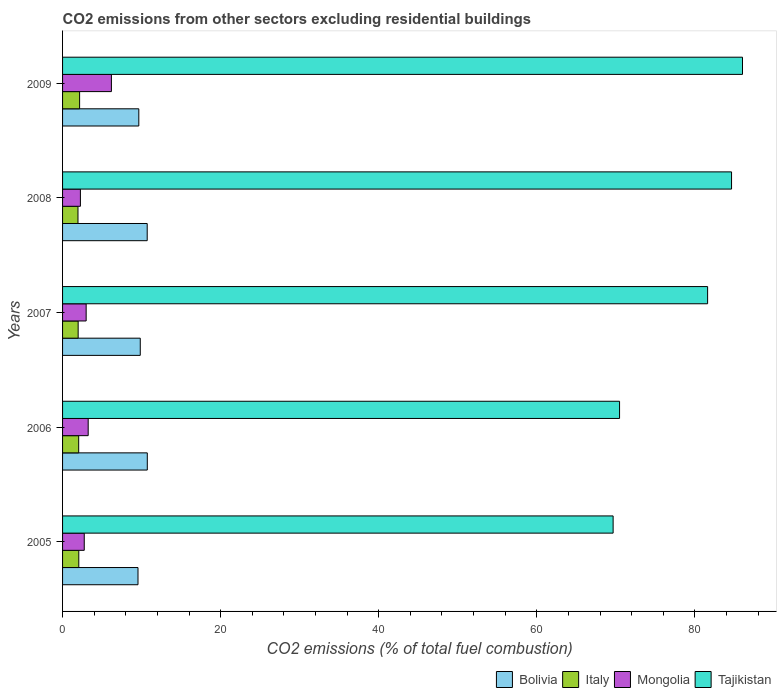How many different coloured bars are there?
Your answer should be very brief. 4. Are the number of bars per tick equal to the number of legend labels?
Offer a terse response. Yes. Are the number of bars on each tick of the Y-axis equal?
Keep it short and to the point. Yes. How many bars are there on the 4th tick from the bottom?
Your answer should be compact. 4. What is the total CO2 emitted in Bolivia in 2009?
Give a very brief answer. 9.65. Across all years, what is the maximum total CO2 emitted in Bolivia?
Offer a terse response. 10.72. Across all years, what is the minimum total CO2 emitted in Italy?
Provide a succinct answer. 1.95. In which year was the total CO2 emitted in Italy maximum?
Make the answer very short. 2009. In which year was the total CO2 emitted in Tajikistan minimum?
Your response must be concise. 2005. What is the total total CO2 emitted in Bolivia in the graph?
Keep it short and to the point. 50.45. What is the difference between the total CO2 emitted in Bolivia in 2006 and that in 2008?
Your answer should be compact. 0.01. What is the difference between the total CO2 emitted in Mongolia in 2005 and the total CO2 emitted in Italy in 2009?
Provide a short and direct response. 0.59. What is the average total CO2 emitted in Italy per year?
Provide a short and direct response. 2.03. In the year 2006, what is the difference between the total CO2 emitted in Mongolia and total CO2 emitted in Bolivia?
Keep it short and to the point. -7.48. In how many years, is the total CO2 emitted in Tajikistan greater than 28 ?
Offer a very short reply. 5. What is the ratio of the total CO2 emitted in Bolivia in 2005 to that in 2006?
Your response must be concise. 0.89. Is the difference between the total CO2 emitted in Mongolia in 2006 and 2008 greater than the difference between the total CO2 emitted in Bolivia in 2006 and 2008?
Ensure brevity in your answer.  Yes. What is the difference between the highest and the second highest total CO2 emitted in Bolivia?
Your answer should be very brief. 0.01. What is the difference between the highest and the lowest total CO2 emitted in Bolivia?
Your answer should be very brief. 1.18. In how many years, is the total CO2 emitted in Tajikistan greater than the average total CO2 emitted in Tajikistan taken over all years?
Ensure brevity in your answer.  3. What does the 4th bar from the top in 2009 represents?
Keep it short and to the point. Bolivia. What does the 3rd bar from the bottom in 2006 represents?
Make the answer very short. Mongolia. How many bars are there?
Your answer should be compact. 20. Are all the bars in the graph horizontal?
Your answer should be compact. Yes. How many years are there in the graph?
Offer a very short reply. 5. What is the difference between two consecutive major ticks on the X-axis?
Offer a terse response. 20. Does the graph contain grids?
Your response must be concise. No. How many legend labels are there?
Ensure brevity in your answer.  4. What is the title of the graph?
Your answer should be very brief. CO2 emissions from other sectors excluding residential buildings. Does "Singapore" appear as one of the legend labels in the graph?
Offer a terse response. No. What is the label or title of the X-axis?
Provide a succinct answer. CO2 emissions (% of total fuel combustion). What is the label or title of the Y-axis?
Provide a succinct answer. Years. What is the CO2 emissions (% of total fuel combustion) of Bolivia in 2005?
Your response must be concise. 9.54. What is the CO2 emissions (% of total fuel combustion) of Italy in 2005?
Offer a very short reply. 2.05. What is the CO2 emissions (% of total fuel combustion) in Mongolia in 2005?
Provide a short and direct response. 2.74. What is the CO2 emissions (% of total fuel combustion) in Tajikistan in 2005?
Offer a very short reply. 69.66. What is the CO2 emissions (% of total fuel combustion) of Bolivia in 2006?
Make the answer very short. 10.72. What is the CO2 emissions (% of total fuel combustion) in Italy in 2006?
Offer a terse response. 2.04. What is the CO2 emissions (% of total fuel combustion) of Mongolia in 2006?
Your response must be concise. 3.24. What is the CO2 emissions (% of total fuel combustion) in Tajikistan in 2006?
Provide a short and direct response. 70.47. What is the CO2 emissions (% of total fuel combustion) of Bolivia in 2007?
Provide a short and direct response. 9.83. What is the CO2 emissions (% of total fuel combustion) in Italy in 2007?
Your answer should be very brief. 1.97. What is the CO2 emissions (% of total fuel combustion) of Mongolia in 2007?
Offer a terse response. 2.98. What is the CO2 emissions (% of total fuel combustion) of Tajikistan in 2007?
Provide a succinct answer. 81.61. What is the CO2 emissions (% of total fuel combustion) in Bolivia in 2008?
Ensure brevity in your answer.  10.71. What is the CO2 emissions (% of total fuel combustion) in Italy in 2008?
Your answer should be very brief. 1.95. What is the CO2 emissions (% of total fuel combustion) of Mongolia in 2008?
Your answer should be compact. 2.26. What is the CO2 emissions (% of total fuel combustion) of Tajikistan in 2008?
Provide a short and direct response. 84.64. What is the CO2 emissions (% of total fuel combustion) in Bolivia in 2009?
Your response must be concise. 9.65. What is the CO2 emissions (% of total fuel combustion) of Italy in 2009?
Keep it short and to the point. 2.16. What is the CO2 emissions (% of total fuel combustion) of Mongolia in 2009?
Give a very brief answer. 6.18. What is the CO2 emissions (% of total fuel combustion) of Tajikistan in 2009?
Offer a terse response. 86.03. Across all years, what is the maximum CO2 emissions (% of total fuel combustion) in Bolivia?
Offer a terse response. 10.72. Across all years, what is the maximum CO2 emissions (% of total fuel combustion) of Italy?
Your response must be concise. 2.16. Across all years, what is the maximum CO2 emissions (% of total fuel combustion) in Mongolia?
Provide a succinct answer. 6.18. Across all years, what is the maximum CO2 emissions (% of total fuel combustion) in Tajikistan?
Your response must be concise. 86.03. Across all years, what is the minimum CO2 emissions (% of total fuel combustion) of Bolivia?
Make the answer very short. 9.54. Across all years, what is the minimum CO2 emissions (% of total fuel combustion) of Italy?
Keep it short and to the point. 1.95. Across all years, what is the minimum CO2 emissions (% of total fuel combustion) in Mongolia?
Offer a terse response. 2.26. Across all years, what is the minimum CO2 emissions (% of total fuel combustion) in Tajikistan?
Keep it short and to the point. 69.66. What is the total CO2 emissions (% of total fuel combustion) of Bolivia in the graph?
Keep it short and to the point. 50.45. What is the total CO2 emissions (% of total fuel combustion) of Italy in the graph?
Give a very brief answer. 10.17. What is the total CO2 emissions (% of total fuel combustion) in Mongolia in the graph?
Provide a succinct answer. 17.4. What is the total CO2 emissions (% of total fuel combustion) of Tajikistan in the graph?
Your response must be concise. 392.41. What is the difference between the CO2 emissions (% of total fuel combustion) in Bolivia in 2005 and that in 2006?
Your answer should be very brief. -1.18. What is the difference between the CO2 emissions (% of total fuel combustion) in Italy in 2005 and that in 2006?
Keep it short and to the point. 0.01. What is the difference between the CO2 emissions (% of total fuel combustion) in Mongolia in 2005 and that in 2006?
Keep it short and to the point. -0.5. What is the difference between the CO2 emissions (% of total fuel combustion) of Tajikistan in 2005 and that in 2006?
Your answer should be compact. -0.81. What is the difference between the CO2 emissions (% of total fuel combustion) of Bolivia in 2005 and that in 2007?
Keep it short and to the point. -0.29. What is the difference between the CO2 emissions (% of total fuel combustion) of Italy in 2005 and that in 2007?
Ensure brevity in your answer.  0.08. What is the difference between the CO2 emissions (% of total fuel combustion) of Mongolia in 2005 and that in 2007?
Provide a short and direct response. -0.24. What is the difference between the CO2 emissions (% of total fuel combustion) of Tajikistan in 2005 and that in 2007?
Give a very brief answer. -11.95. What is the difference between the CO2 emissions (% of total fuel combustion) of Bolivia in 2005 and that in 2008?
Your answer should be very brief. -1.16. What is the difference between the CO2 emissions (% of total fuel combustion) in Italy in 2005 and that in 2008?
Provide a succinct answer. 0.1. What is the difference between the CO2 emissions (% of total fuel combustion) of Mongolia in 2005 and that in 2008?
Keep it short and to the point. 0.49. What is the difference between the CO2 emissions (% of total fuel combustion) of Tajikistan in 2005 and that in 2008?
Ensure brevity in your answer.  -14.98. What is the difference between the CO2 emissions (% of total fuel combustion) of Bolivia in 2005 and that in 2009?
Your answer should be very brief. -0.1. What is the difference between the CO2 emissions (% of total fuel combustion) of Italy in 2005 and that in 2009?
Offer a very short reply. -0.1. What is the difference between the CO2 emissions (% of total fuel combustion) in Mongolia in 2005 and that in 2009?
Your answer should be compact. -3.44. What is the difference between the CO2 emissions (% of total fuel combustion) in Tajikistan in 2005 and that in 2009?
Provide a succinct answer. -16.37. What is the difference between the CO2 emissions (% of total fuel combustion) of Bolivia in 2006 and that in 2007?
Your answer should be very brief. 0.89. What is the difference between the CO2 emissions (% of total fuel combustion) of Italy in 2006 and that in 2007?
Your answer should be compact. 0.07. What is the difference between the CO2 emissions (% of total fuel combustion) of Mongolia in 2006 and that in 2007?
Offer a terse response. 0.26. What is the difference between the CO2 emissions (% of total fuel combustion) in Tajikistan in 2006 and that in 2007?
Provide a short and direct response. -11.14. What is the difference between the CO2 emissions (% of total fuel combustion) in Bolivia in 2006 and that in 2008?
Give a very brief answer. 0.01. What is the difference between the CO2 emissions (% of total fuel combustion) of Italy in 2006 and that in 2008?
Ensure brevity in your answer.  0.09. What is the difference between the CO2 emissions (% of total fuel combustion) in Mongolia in 2006 and that in 2008?
Provide a short and direct response. 0.98. What is the difference between the CO2 emissions (% of total fuel combustion) in Tajikistan in 2006 and that in 2008?
Your answer should be very brief. -14.17. What is the difference between the CO2 emissions (% of total fuel combustion) in Bolivia in 2006 and that in 2009?
Provide a succinct answer. 1.07. What is the difference between the CO2 emissions (% of total fuel combustion) in Italy in 2006 and that in 2009?
Offer a terse response. -0.12. What is the difference between the CO2 emissions (% of total fuel combustion) of Mongolia in 2006 and that in 2009?
Keep it short and to the point. -2.94. What is the difference between the CO2 emissions (% of total fuel combustion) in Tajikistan in 2006 and that in 2009?
Provide a succinct answer. -15.55. What is the difference between the CO2 emissions (% of total fuel combustion) of Bolivia in 2007 and that in 2008?
Provide a succinct answer. -0.88. What is the difference between the CO2 emissions (% of total fuel combustion) in Italy in 2007 and that in 2008?
Offer a very short reply. 0.02. What is the difference between the CO2 emissions (% of total fuel combustion) of Mongolia in 2007 and that in 2008?
Make the answer very short. 0.73. What is the difference between the CO2 emissions (% of total fuel combustion) of Tajikistan in 2007 and that in 2008?
Your answer should be very brief. -3.03. What is the difference between the CO2 emissions (% of total fuel combustion) of Bolivia in 2007 and that in 2009?
Give a very brief answer. 0.18. What is the difference between the CO2 emissions (% of total fuel combustion) of Italy in 2007 and that in 2009?
Make the answer very short. -0.18. What is the difference between the CO2 emissions (% of total fuel combustion) in Mongolia in 2007 and that in 2009?
Your answer should be very brief. -3.2. What is the difference between the CO2 emissions (% of total fuel combustion) of Tajikistan in 2007 and that in 2009?
Offer a terse response. -4.41. What is the difference between the CO2 emissions (% of total fuel combustion) of Bolivia in 2008 and that in 2009?
Your answer should be very brief. 1.06. What is the difference between the CO2 emissions (% of total fuel combustion) in Italy in 2008 and that in 2009?
Keep it short and to the point. -0.21. What is the difference between the CO2 emissions (% of total fuel combustion) of Mongolia in 2008 and that in 2009?
Offer a terse response. -3.92. What is the difference between the CO2 emissions (% of total fuel combustion) in Tajikistan in 2008 and that in 2009?
Provide a short and direct response. -1.38. What is the difference between the CO2 emissions (% of total fuel combustion) in Bolivia in 2005 and the CO2 emissions (% of total fuel combustion) in Italy in 2006?
Ensure brevity in your answer.  7.5. What is the difference between the CO2 emissions (% of total fuel combustion) of Bolivia in 2005 and the CO2 emissions (% of total fuel combustion) of Mongolia in 2006?
Make the answer very short. 6.3. What is the difference between the CO2 emissions (% of total fuel combustion) in Bolivia in 2005 and the CO2 emissions (% of total fuel combustion) in Tajikistan in 2006?
Ensure brevity in your answer.  -60.93. What is the difference between the CO2 emissions (% of total fuel combustion) of Italy in 2005 and the CO2 emissions (% of total fuel combustion) of Mongolia in 2006?
Provide a succinct answer. -1.19. What is the difference between the CO2 emissions (% of total fuel combustion) in Italy in 2005 and the CO2 emissions (% of total fuel combustion) in Tajikistan in 2006?
Keep it short and to the point. -68.42. What is the difference between the CO2 emissions (% of total fuel combustion) in Mongolia in 2005 and the CO2 emissions (% of total fuel combustion) in Tajikistan in 2006?
Give a very brief answer. -67.73. What is the difference between the CO2 emissions (% of total fuel combustion) in Bolivia in 2005 and the CO2 emissions (% of total fuel combustion) in Italy in 2007?
Make the answer very short. 7.57. What is the difference between the CO2 emissions (% of total fuel combustion) of Bolivia in 2005 and the CO2 emissions (% of total fuel combustion) of Mongolia in 2007?
Offer a terse response. 6.56. What is the difference between the CO2 emissions (% of total fuel combustion) in Bolivia in 2005 and the CO2 emissions (% of total fuel combustion) in Tajikistan in 2007?
Provide a succinct answer. -72.07. What is the difference between the CO2 emissions (% of total fuel combustion) in Italy in 2005 and the CO2 emissions (% of total fuel combustion) in Mongolia in 2007?
Your answer should be very brief. -0.93. What is the difference between the CO2 emissions (% of total fuel combustion) in Italy in 2005 and the CO2 emissions (% of total fuel combustion) in Tajikistan in 2007?
Offer a terse response. -79.56. What is the difference between the CO2 emissions (% of total fuel combustion) in Mongolia in 2005 and the CO2 emissions (% of total fuel combustion) in Tajikistan in 2007?
Provide a succinct answer. -78.87. What is the difference between the CO2 emissions (% of total fuel combustion) in Bolivia in 2005 and the CO2 emissions (% of total fuel combustion) in Italy in 2008?
Give a very brief answer. 7.59. What is the difference between the CO2 emissions (% of total fuel combustion) of Bolivia in 2005 and the CO2 emissions (% of total fuel combustion) of Mongolia in 2008?
Give a very brief answer. 7.29. What is the difference between the CO2 emissions (% of total fuel combustion) of Bolivia in 2005 and the CO2 emissions (% of total fuel combustion) of Tajikistan in 2008?
Offer a terse response. -75.1. What is the difference between the CO2 emissions (% of total fuel combustion) of Italy in 2005 and the CO2 emissions (% of total fuel combustion) of Mongolia in 2008?
Your response must be concise. -0.2. What is the difference between the CO2 emissions (% of total fuel combustion) in Italy in 2005 and the CO2 emissions (% of total fuel combustion) in Tajikistan in 2008?
Your answer should be very brief. -82.59. What is the difference between the CO2 emissions (% of total fuel combustion) of Mongolia in 2005 and the CO2 emissions (% of total fuel combustion) of Tajikistan in 2008?
Your answer should be compact. -81.9. What is the difference between the CO2 emissions (% of total fuel combustion) of Bolivia in 2005 and the CO2 emissions (% of total fuel combustion) of Italy in 2009?
Provide a succinct answer. 7.39. What is the difference between the CO2 emissions (% of total fuel combustion) in Bolivia in 2005 and the CO2 emissions (% of total fuel combustion) in Mongolia in 2009?
Your answer should be compact. 3.36. What is the difference between the CO2 emissions (% of total fuel combustion) in Bolivia in 2005 and the CO2 emissions (% of total fuel combustion) in Tajikistan in 2009?
Keep it short and to the point. -76.48. What is the difference between the CO2 emissions (% of total fuel combustion) in Italy in 2005 and the CO2 emissions (% of total fuel combustion) in Mongolia in 2009?
Provide a succinct answer. -4.13. What is the difference between the CO2 emissions (% of total fuel combustion) of Italy in 2005 and the CO2 emissions (% of total fuel combustion) of Tajikistan in 2009?
Your response must be concise. -83.97. What is the difference between the CO2 emissions (% of total fuel combustion) of Mongolia in 2005 and the CO2 emissions (% of total fuel combustion) of Tajikistan in 2009?
Offer a very short reply. -83.28. What is the difference between the CO2 emissions (% of total fuel combustion) in Bolivia in 2006 and the CO2 emissions (% of total fuel combustion) in Italy in 2007?
Give a very brief answer. 8.75. What is the difference between the CO2 emissions (% of total fuel combustion) in Bolivia in 2006 and the CO2 emissions (% of total fuel combustion) in Mongolia in 2007?
Give a very brief answer. 7.74. What is the difference between the CO2 emissions (% of total fuel combustion) in Bolivia in 2006 and the CO2 emissions (% of total fuel combustion) in Tajikistan in 2007?
Give a very brief answer. -70.89. What is the difference between the CO2 emissions (% of total fuel combustion) in Italy in 2006 and the CO2 emissions (% of total fuel combustion) in Mongolia in 2007?
Keep it short and to the point. -0.94. What is the difference between the CO2 emissions (% of total fuel combustion) of Italy in 2006 and the CO2 emissions (% of total fuel combustion) of Tajikistan in 2007?
Your response must be concise. -79.57. What is the difference between the CO2 emissions (% of total fuel combustion) of Mongolia in 2006 and the CO2 emissions (% of total fuel combustion) of Tajikistan in 2007?
Keep it short and to the point. -78.37. What is the difference between the CO2 emissions (% of total fuel combustion) in Bolivia in 2006 and the CO2 emissions (% of total fuel combustion) in Italy in 2008?
Your answer should be compact. 8.77. What is the difference between the CO2 emissions (% of total fuel combustion) of Bolivia in 2006 and the CO2 emissions (% of total fuel combustion) of Mongolia in 2008?
Ensure brevity in your answer.  8.46. What is the difference between the CO2 emissions (% of total fuel combustion) in Bolivia in 2006 and the CO2 emissions (% of total fuel combustion) in Tajikistan in 2008?
Keep it short and to the point. -73.92. What is the difference between the CO2 emissions (% of total fuel combustion) in Italy in 2006 and the CO2 emissions (% of total fuel combustion) in Mongolia in 2008?
Ensure brevity in your answer.  -0.22. What is the difference between the CO2 emissions (% of total fuel combustion) of Italy in 2006 and the CO2 emissions (% of total fuel combustion) of Tajikistan in 2008?
Offer a terse response. -82.6. What is the difference between the CO2 emissions (% of total fuel combustion) of Mongolia in 2006 and the CO2 emissions (% of total fuel combustion) of Tajikistan in 2008?
Offer a terse response. -81.4. What is the difference between the CO2 emissions (% of total fuel combustion) of Bolivia in 2006 and the CO2 emissions (% of total fuel combustion) of Italy in 2009?
Give a very brief answer. 8.56. What is the difference between the CO2 emissions (% of total fuel combustion) in Bolivia in 2006 and the CO2 emissions (% of total fuel combustion) in Mongolia in 2009?
Your answer should be compact. 4.54. What is the difference between the CO2 emissions (% of total fuel combustion) in Bolivia in 2006 and the CO2 emissions (% of total fuel combustion) in Tajikistan in 2009?
Keep it short and to the point. -75.31. What is the difference between the CO2 emissions (% of total fuel combustion) of Italy in 2006 and the CO2 emissions (% of total fuel combustion) of Mongolia in 2009?
Keep it short and to the point. -4.14. What is the difference between the CO2 emissions (% of total fuel combustion) in Italy in 2006 and the CO2 emissions (% of total fuel combustion) in Tajikistan in 2009?
Your answer should be very brief. -83.99. What is the difference between the CO2 emissions (% of total fuel combustion) in Mongolia in 2006 and the CO2 emissions (% of total fuel combustion) in Tajikistan in 2009?
Give a very brief answer. -82.78. What is the difference between the CO2 emissions (% of total fuel combustion) in Bolivia in 2007 and the CO2 emissions (% of total fuel combustion) in Italy in 2008?
Offer a very short reply. 7.88. What is the difference between the CO2 emissions (% of total fuel combustion) of Bolivia in 2007 and the CO2 emissions (% of total fuel combustion) of Mongolia in 2008?
Your answer should be very brief. 7.57. What is the difference between the CO2 emissions (% of total fuel combustion) of Bolivia in 2007 and the CO2 emissions (% of total fuel combustion) of Tajikistan in 2008?
Offer a terse response. -74.81. What is the difference between the CO2 emissions (% of total fuel combustion) of Italy in 2007 and the CO2 emissions (% of total fuel combustion) of Mongolia in 2008?
Keep it short and to the point. -0.28. What is the difference between the CO2 emissions (% of total fuel combustion) of Italy in 2007 and the CO2 emissions (% of total fuel combustion) of Tajikistan in 2008?
Offer a very short reply. -82.67. What is the difference between the CO2 emissions (% of total fuel combustion) of Mongolia in 2007 and the CO2 emissions (% of total fuel combustion) of Tajikistan in 2008?
Your answer should be very brief. -81.66. What is the difference between the CO2 emissions (% of total fuel combustion) in Bolivia in 2007 and the CO2 emissions (% of total fuel combustion) in Italy in 2009?
Provide a short and direct response. 7.67. What is the difference between the CO2 emissions (% of total fuel combustion) in Bolivia in 2007 and the CO2 emissions (% of total fuel combustion) in Mongolia in 2009?
Provide a short and direct response. 3.65. What is the difference between the CO2 emissions (% of total fuel combustion) of Bolivia in 2007 and the CO2 emissions (% of total fuel combustion) of Tajikistan in 2009?
Make the answer very short. -76.2. What is the difference between the CO2 emissions (% of total fuel combustion) of Italy in 2007 and the CO2 emissions (% of total fuel combustion) of Mongolia in 2009?
Ensure brevity in your answer.  -4.21. What is the difference between the CO2 emissions (% of total fuel combustion) in Italy in 2007 and the CO2 emissions (% of total fuel combustion) in Tajikistan in 2009?
Offer a terse response. -84.05. What is the difference between the CO2 emissions (% of total fuel combustion) of Mongolia in 2007 and the CO2 emissions (% of total fuel combustion) of Tajikistan in 2009?
Give a very brief answer. -83.04. What is the difference between the CO2 emissions (% of total fuel combustion) of Bolivia in 2008 and the CO2 emissions (% of total fuel combustion) of Italy in 2009?
Keep it short and to the point. 8.55. What is the difference between the CO2 emissions (% of total fuel combustion) in Bolivia in 2008 and the CO2 emissions (% of total fuel combustion) in Mongolia in 2009?
Offer a terse response. 4.53. What is the difference between the CO2 emissions (% of total fuel combustion) in Bolivia in 2008 and the CO2 emissions (% of total fuel combustion) in Tajikistan in 2009?
Offer a terse response. -75.32. What is the difference between the CO2 emissions (% of total fuel combustion) of Italy in 2008 and the CO2 emissions (% of total fuel combustion) of Mongolia in 2009?
Provide a short and direct response. -4.23. What is the difference between the CO2 emissions (% of total fuel combustion) in Italy in 2008 and the CO2 emissions (% of total fuel combustion) in Tajikistan in 2009?
Provide a short and direct response. -84.08. What is the difference between the CO2 emissions (% of total fuel combustion) of Mongolia in 2008 and the CO2 emissions (% of total fuel combustion) of Tajikistan in 2009?
Your response must be concise. -83.77. What is the average CO2 emissions (% of total fuel combustion) in Bolivia per year?
Ensure brevity in your answer.  10.09. What is the average CO2 emissions (% of total fuel combustion) of Italy per year?
Your answer should be very brief. 2.03. What is the average CO2 emissions (% of total fuel combustion) of Mongolia per year?
Keep it short and to the point. 3.48. What is the average CO2 emissions (% of total fuel combustion) of Tajikistan per year?
Give a very brief answer. 78.48. In the year 2005, what is the difference between the CO2 emissions (% of total fuel combustion) in Bolivia and CO2 emissions (% of total fuel combustion) in Italy?
Make the answer very short. 7.49. In the year 2005, what is the difference between the CO2 emissions (% of total fuel combustion) of Bolivia and CO2 emissions (% of total fuel combustion) of Mongolia?
Make the answer very short. 6.8. In the year 2005, what is the difference between the CO2 emissions (% of total fuel combustion) of Bolivia and CO2 emissions (% of total fuel combustion) of Tajikistan?
Your response must be concise. -60.11. In the year 2005, what is the difference between the CO2 emissions (% of total fuel combustion) in Italy and CO2 emissions (% of total fuel combustion) in Mongolia?
Keep it short and to the point. -0.69. In the year 2005, what is the difference between the CO2 emissions (% of total fuel combustion) in Italy and CO2 emissions (% of total fuel combustion) in Tajikistan?
Provide a succinct answer. -67.61. In the year 2005, what is the difference between the CO2 emissions (% of total fuel combustion) in Mongolia and CO2 emissions (% of total fuel combustion) in Tajikistan?
Your answer should be compact. -66.92. In the year 2006, what is the difference between the CO2 emissions (% of total fuel combustion) in Bolivia and CO2 emissions (% of total fuel combustion) in Italy?
Your response must be concise. 8.68. In the year 2006, what is the difference between the CO2 emissions (% of total fuel combustion) of Bolivia and CO2 emissions (% of total fuel combustion) of Mongolia?
Your response must be concise. 7.48. In the year 2006, what is the difference between the CO2 emissions (% of total fuel combustion) in Bolivia and CO2 emissions (% of total fuel combustion) in Tajikistan?
Keep it short and to the point. -59.75. In the year 2006, what is the difference between the CO2 emissions (% of total fuel combustion) in Italy and CO2 emissions (% of total fuel combustion) in Mongolia?
Ensure brevity in your answer.  -1.2. In the year 2006, what is the difference between the CO2 emissions (% of total fuel combustion) in Italy and CO2 emissions (% of total fuel combustion) in Tajikistan?
Provide a short and direct response. -68.43. In the year 2006, what is the difference between the CO2 emissions (% of total fuel combustion) of Mongolia and CO2 emissions (% of total fuel combustion) of Tajikistan?
Keep it short and to the point. -67.23. In the year 2007, what is the difference between the CO2 emissions (% of total fuel combustion) of Bolivia and CO2 emissions (% of total fuel combustion) of Italy?
Your response must be concise. 7.86. In the year 2007, what is the difference between the CO2 emissions (% of total fuel combustion) of Bolivia and CO2 emissions (% of total fuel combustion) of Mongolia?
Offer a very short reply. 6.85. In the year 2007, what is the difference between the CO2 emissions (% of total fuel combustion) in Bolivia and CO2 emissions (% of total fuel combustion) in Tajikistan?
Your response must be concise. -71.78. In the year 2007, what is the difference between the CO2 emissions (% of total fuel combustion) in Italy and CO2 emissions (% of total fuel combustion) in Mongolia?
Offer a terse response. -1.01. In the year 2007, what is the difference between the CO2 emissions (% of total fuel combustion) of Italy and CO2 emissions (% of total fuel combustion) of Tajikistan?
Give a very brief answer. -79.64. In the year 2007, what is the difference between the CO2 emissions (% of total fuel combustion) in Mongolia and CO2 emissions (% of total fuel combustion) in Tajikistan?
Make the answer very short. -78.63. In the year 2008, what is the difference between the CO2 emissions (% of total fuel combustion) of Bolivia and CO2 emissions (% of total fuel combustion) of Italy?
Provide a succinct answer. 8.76. In the year 2008, what is the difference between the CO2 emissions (% of total fuel combustion) of Bolivia and CO2 emissions (% of total fuel combustion) of Mongolia?
Keep it short and to the point. 8.45. In the year 2008, what is the difference between the CO2 emissions (% of total fuel combustion) of Bolivia and CO2 emissions (% of total fuel combustion) of Tajikistan?
Provide a short and direct response. -73.93. In the year 2008, what is the difference between the CO2 emissions (% of total fuel combustion) of Italy and CO2 emissions (% of total fuel combustion) of Mongolia?
Your response must be concise. -0.31. In the year 2008, what is the difference between the CO2 emissions (% of total fuel combustion) in Italy and CO2 emissions (% of total fuel combustion) in Tajikistan?
Keep it short and to the point. -82.69. In the year 2008, what is the difference between the CO2 emissions (% of total fuel combustion) in Mongolia and CO2 emissions (% of total fuel combustion) in Tajikistan?
Keep it short and to the point. -82.39. In the year 2009, what is the difference between the CO2 emissions (% of total fuel combustion) in Bolivia and CO2 emissions (% of total fuel combustion) in Italy?
Your response must be concise. 7.49. In the year 2009, what is the difference between the CO2 emissions (% of total fuel combustion) in Bolivia and CO2 emissions (% of total fuel combustion) in Mongolia?
Make the answer very short. 3.47. In the year 2009, what is the difference between the CO2 emissions (% of total fuel combustion) in Bolivia and CO2 emissions (% of total fuel combustion) in Tajikistan?
Make the answer very short. -76.38. In the year 2009, what is the difference between the CO2 emissions (% of total fuel combustion) in Italy and CO2 emissions (% of total fuel combustion) in Mongolia?
Keep it short and to the point. -4.02. In the year 2009, what is the difference between the CO2 emissions (% of total fuel combustion) of Italy and CO2 emissions (% of total fuel combustion) of Tajikistan?
Offer a terse response. -83.87. In the year 2009, what is the difference between the CO2 emissions (% of total fuel combustion) in Mongolia and CO2 emissions (% of total fuel combustion) in Tajikistan?
Keep it short and to the point. -79.85. What is the ratio of the CO2 emissions (% of total fuel combustion) of Bolivia in 2005 to that in 2006?
Offer a terse response. 0.89. What is the ratio of the CO2 emissions (% of total fuel combustion) in Mongolia in 2005 to that in 2006?
Offer a very short reply. 0.85. What is the ratio of the CO2 emissions (% of total fuel combustion) in Tajikistan in 2005 to that in 2006?
Make the answer very short. 0.99. What is the ratio of the CO2 emissions (% of total fuel combustion) in Bolivia in 2005 to that in 2007?
Offer a terse response. 0.97. What is the ratio of the CO2 emissions (% of total fuel combustion) of Italy in 2005 to that in 2007?
Provide a short and direct response. 1.04. What is the ratio of the CO2 emissions (% of total fuel combustion) of Mongolia in 2005 to that in 2007?
Provide a succinct answer. 0.92. What is the ratio of the CO2 emissions (% of total fuel combustion) of Tajikistan in 2005 to that in 2007?
Make the answer very short. 0.85. What is the ratio of the CO2 emissions (% of total fuel combustion) of Bolivia in 2005 to that in 2008?
Give a very brief answer. 0.89. What is the ratio of the CO2 emissions (% of total fuel combustion) in Italy in 2005 to that in 2008?
Your answer should be compact. 1.05. What is the ratio of the CO2 emissions (% of total fuel combustion) of Mongolia in 2005 to that in 2008?
Keep it short and to the point. 1.22. What is the ratio of the CO2 emissions (% of total fuel combustion) of Tajikistan in 2005 to that in 2008?
Your answer should be very brief. 0.82. What is the ratio of the CO2 emissions (% of total fuel combustion) in Bolivia in 2005 to that in 2009?
Ensure brevity in your answer.  0.99. What is the ratio of the CO2 emissions (% of total fuel combustion) in Italy in 2005 to that in 2009?
Provide a succinct answer. 0.95. What is the ratio of the CO2 emissions (% of total fuel combustion) in Mongolia in 2005 to that in 2009?
Offer a terse response. 0.44. What is the ratio of the CO2 emissions (% of total fuel combustion) in Tajikistan in 2005 to that in 2009?
Ensure brevity in your answer.  0.81. What is the ratio of the CO2 emissions (% of total fuel combustion) in Bolivia in 2006 to that in 2007?
Provide a succinct answer. 1.09. What is the ratio of the CO2 emissions (% of total fuel combustion) in Italy in 2006 to that in 2007?
Provide a short and direct response. 1.03. What is the ratio of the CO2 emissions (% of total fuel combustion) in Mongolia in 2006 to that in 2007?
Give a very brief answer. 1.09. What is the ratio of the CO2 emissions (% of total fuel combustion) in Tajikistan in 2006 to that in 2007?
Provide a short and direct response. 0.86. What is the ratio of the CO2 emissions (% of total fuel combustion) in Italy in 2006 to that in 2008?
Provide a succinct answer. 1.05. What is the ratio of the CO2 emissions (% of total fuel combustion) in Mongolia in 2006 to that in 2008?
Your answer should be compact. 1.44. What is the ratio of the CO2 emissions (% of total fuel combustion) of Tajikistan in 2006 to that in 2008?
Ensure brevity in your answer.  0.83. What is the ratio of the CO2 emissions (% of total fuel combustion) in Bolivia in 2006 to that in 2009?
Keep it short and to the point. 1.11. What is the ratio of the CO2 emissions (% of total fuel combustion) in Italy in 2006 to that in 2009?
Provide a short and direct response. 0.95. What is the ratio of the CO2 emissions (% of total fuel combustion) of Mongolia in 2006 to that in 2009?
Keep it short and to the point. 0.52. What is the ratio of the CO2 emissions (% of total fuel combustion) in Tajikistan in 2006 to that in 2009?
Make the answer very short. 0.82. What is the ratio of the CO2 emissions (% of total fuel combustion) of Bolivia in 2007 to that in 2008?
Ensure brevity in your answer.  0.92. What is the ratio of the CO2 emissions (% of total fuel combustion) in Italy in 2007 to that in 2008?
Offer a terse response. 1.01. What is the ratio of the CO2 emissions (% of total fuel combustion) of Mongolia in 2007 to that in 2008?
Provide a short and direct response. 1.32. What is the ratio of the CO2 emissions (% of total fuel combustion) in Tajikistan in 2007 to that in 2008?
Your response must be concise. 0.96. What is the ratio of the CO2 emissions (% of total fuel combustion) in Bolivia in 2007 to that in 2009?
Your answer should be compact. 1.02. What is the ratio of the CO2 emissions (% of total fuel combustion) in Italy in 2007 to that in 2009?
Your answer should be very brief. 0.91. What is the ratio of the CO2 emissions (% of total fuel combustion) in Mongolia in 2007 to that in 2009?
Give a very brief answer. 0.48. What is the ratio of the CO2 emissions (% of total fuel combustion) of Tajikistan in 2007 to that in 2009?
Your response must be concise. 0.95. What is the ratio of the CO2 emissions (% of total fuel combustion) of Bolivia in 2008 to that in 2009?
Provide a succinct answer. 1.11. What is the ratio of the CO2 emissions (% of total fuel combustion) in Italy in 2008 to that in 2009?
Offer a terse response. 0.9. What is the ratio of the CO2 emissions (% of total fuel combustion) in Mongolia in 2008 to that in 2009?
Offer a very short reply. 0.37. What is the ratio of the CO2 emissions (% of total fuel combustion) in Tajikistan in 2008 to that in 2009?
Your answer should be compact. 0.98. What is the difference between the highest and the second highest CO2 emissions (% of total fuel combustion) in Bolivia?
Make the answer very short. 0.01. What is the difference between the highest and the second highest CO2 emissions (% of total fuel combustion) in Italy?
Offer a very short reply. 0.1. What is the difference between the highest and the second highest CO2 emissions (% of total fuel combustion) of Mongolia?
Provide a succinct answer. 2.94. What is the difference between the highest and the second highest CO2 emissions (% of total fuel combustion) of Tajikistan?
Offer a very short reply. 1.38. What is the difference between the highest and the lowest CO2 emissions (% of total fuel combustion) of Bolivia?
Your answer should be compact. 1.18. What is the difference between the highest and the lowest CO2 emissions (% of total fuel combustion) in Italy?
Provide a short and direct response. 0.21. What is the difference between the highest and the lowest CO2 emissions (% of total fuel combustion) in Mongolia?
Make the answer very short. 3.92. What is the difference between the highest and the lowest CO2 emissions (% of total fuel combustion) of Tajikistan?
Offer a very short reply. 16.37. 